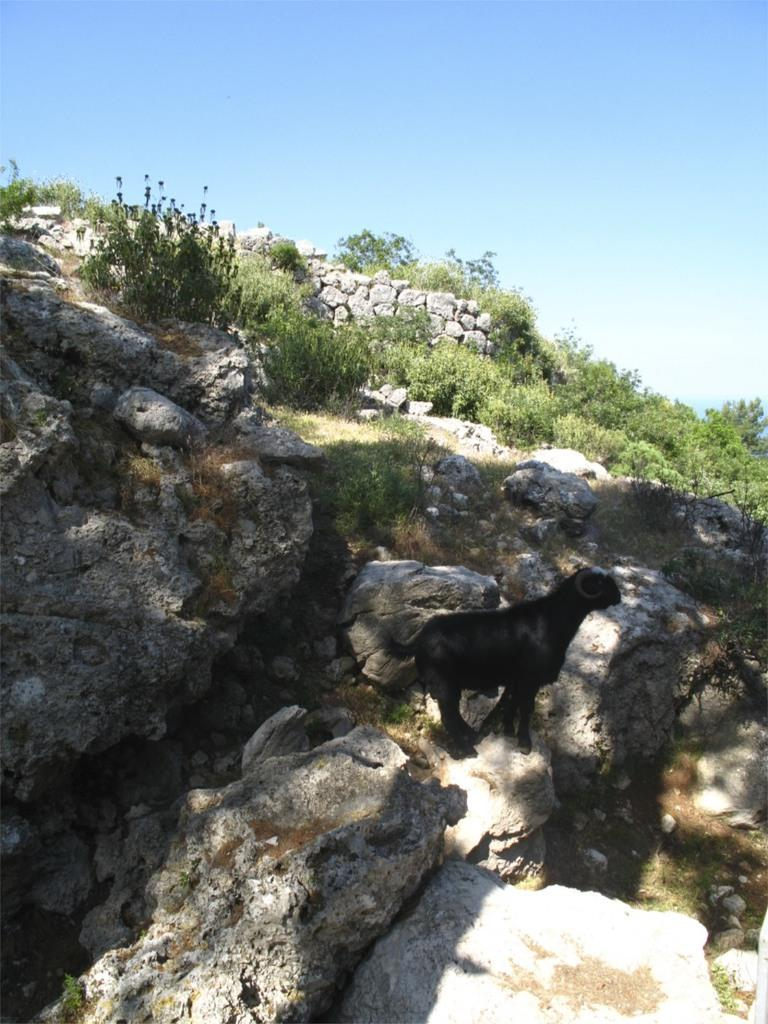What animal is present in the image? There is a goat in the image. What is the color of the goat? The goat is black in color. Where is the goat located in the image? The goat is on a rock. What other objects or features can be seen in the image? There are rocks and plants in the image. What can be seen in the background of the image? The sky is visible in the background of the image. Is the goat playing a guitar in the image? No, there is no guitar present in the image, and the goat is not playing any musical instrument. 